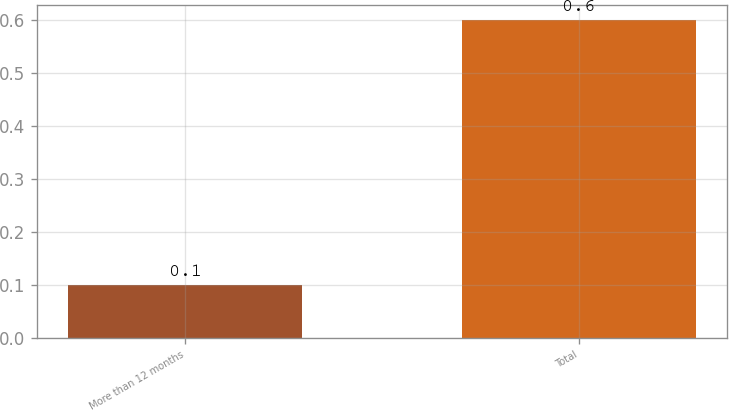Convert chart. <chart><loc_0><loc_0><loc_500><loc_500><bar_chart><fcel>More than 12 months<fcel>Total<nl><fcel>0.1<fcel>0.6<nl></chart> 